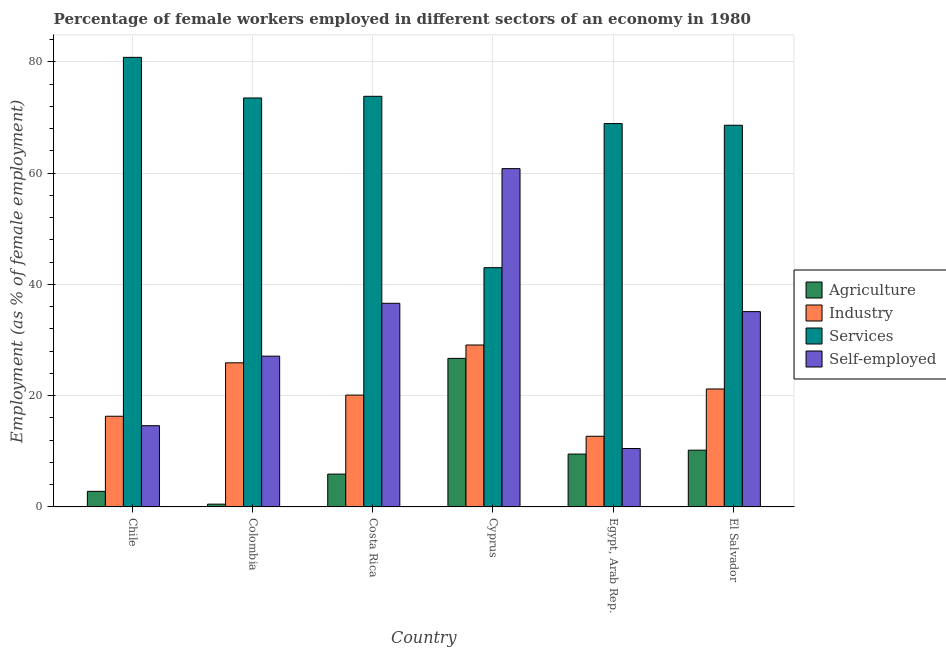How many groups of bars are there?
Your answer should be compact. 6. How many bars are there on the 3rd tick from the left?
Give a very brief answer. 4. What is the label of the 6th group of bars from the left?
Your answer should be very brief. El Salvador. In how many cases, is the number of bars for a given country not equal to the number of legend labels?
Ensure brevity in your answer.  0. What is the percentage of self employed female workers in El Salvador?
Ensure brevity in your answer.  35.1. Across all countries, what is the maximum percentage of female workers in services?
Your response must be concise. 80.8. Across all countries, what is the minimum percentage of female workers in agriculture?
Offer a terse response. 0.5. In which country was the percentage of female workers in agriculture maximum?
Offer a terse response. Cyprus. In which country was the percentage of female workers in services minimum?
Provide a succinct answer. Cyprus. What is the total percentage of female workers in services in the graph?
Give a very brief answer. 408.6. What is the difference between the percentage of female workers in industry in Chile and that in Egypt, Arab Rep.?
Your response must be concise. 3.6. What is the difference between the percentage of female workers in industry in Chile and the percentage of female workers in services in Costa Rica?
Give a very brief answer. -57.5. What is the average percentage of self employed female workers per country?
Your answer should be compact. 30.78. What is the difference between the percentage of female workers in services and percentage of female workers in agriculture in Chile?
Offer a terse response. 78. What is the ratio of the percentage of female workers in services in Chile to that in Costa Rica?
Keep it short and to the point. 1.09. Is the percentage of female workers in services in Chile less than that in Cyprus?
Ensure brevity in your answer.  No. Is the difference between the percentage of self employed female workers in Cyprus and Egypt, Arab Rep. greater than the difference between the percentage of female workers in services in Cyprus and Egypt, Arab Rep.?
Give a very brief answer. Yes. What is the difference between the highest and the second highest percentage of self employed female workers?
Keep it short and to the point. 24.2. What is the difference between the highest and the lowest percentage of female workers in industry?
Offer a very short reply. 16.4. In how many countries, is the percentage of self employed female workers greater than the average percentage of self employed female workers taken over all countries?
Provide a short and direct response. 3. Is it the case that in every country, the sum of the percentage of female workers in services and percentage of self employed female workers is greater than the sum of percentage of female workers in industry and percentage of female workers in agriculture?
Your response must be concise. No. What does the 4th bar from the left in Cyprus represents?
Offer a very short reply. Self-employed. What does the 1st bar from the right in Chile represents?
Ensure brevity in your answer.  Self-employed. How many countries are there in the graph?
Your response must be concise. 6. What is the difference between two consecutive major ticks on the Y-axis?
Ensure brevity in your answer.  20. Does the graph contain grids?
Your answer should be very brief. Yes. Where does the legend appear in the graph?
Your answer should be compact. Center right. How are the legend labels stacked?
Ensure brevity in your answer.  Vertical. What is the title of the graph?
Give a very brief answer. Percentage of female workers employed in different sectors of an economy in 1980. What is the label or title of the Y-axis?
Offer a terse response. Employment (as % of female employment). What is the Employment (as % of female employment) of Agriculture in Chile?
Provide a succinct answer. 2.8. What is the Employment (as % of female employment) in Industry in Chile?
Offer a very short reply. 16.3. What is the Employment (as % of female employment) of Services in Chile?
Make the answer very short. 80.8. What is the Employment (as % of female employment) of Self-employed in Chile?
Your answer should be compact. 14.6. What is the Employment (as % of female employment) in Agriculture in Colombia?
Offer a terse response. 0.5. What is the Employment (as % of female employment) in Industry in Colombia?
Offer a terse response. 25.9. What is the Employment (as % of female employment) in Services in Colombia?
Provide a short and direct response. 73.5. What is the Employment (as % of female employment) of Self-employed in Colombia?
Give a very brief answer. 27.1. What is the Employment (as % of female employment) of Agriculture in Costa Rica?
Offer a terse response. 5.9. What is the Employment (as % of female employment) in Industry in Costa Rica?
Offer a terse response. 20.1. What is the Employment (as % of female employment) in Services in Costa Rica?
Offer a very short reply. 73.8. What is the Employment (as % of female employment) of Self-employed in Costa Rica?
Offer a very short reply. 36.6. What is the Employment (as % of female employment) of Agriculture in Cyprus?
Provide a succinct answer. 26.7. What is the Employment (as % of female employment) in Industry in Cyprus?
Make the answer very short. 29.1. What is the Employment (as % of female employment) in Services in Cyprus?
Keep it short and to the point. 43. What is the Employment (as % of female employment) of Self-employed in Cyprus?
Provide a short and direct response. 60.8. What is the Employment (as % of female employment) in Agriculture in Egypt, Arab Rep.?
Your response must be concise. 9.5. What is the Employment (as % of female employment) of Industry in Egypt, Arab Rep.?
Make the answer very short. 12.7. What is the Employment (as % of female employment) of Services in Egypt, Arab Rep.?
Your response must be concise. 68.9. What is the Employment (as % of female employment) of Self-employed in Egypt, Arab Rep.?
Provide a short and direct response. 10.5. What is the Employment (as % of female employment) of Agriculture in El Salvador?
Provide a succinct answer. 10.2. What is the Employment (as % of female employment) of Industry in El Salvador?
Your response must be concise. 21.2. What is the Employment (as % of female employment) in Services in El Salvador?
Offer a very short reply. 68.6. What is the Employment (as % of female employment) of Self-employed in El Salvador?
Provide a succinct answer. 35.1. Across all countries, what is the maximum Employment (as % of female employment) of Agriculture?
Provide a short and direct response. 26.7. Across all countries, what is the maximum Employment (as % of female employment) in Industry?
Your answer should be compact. 29.1. Across all countries, what is the maximum Employment (as % of female employment) of Services?
Provide a short and direct response. 80.8. Across all countries, what is the maximum Employment (as % of female employment) of Self-employed?
Make the answer very short. 60.8. Across all countries, what is the minimum Employment (as % of female employment) in Industry?
Offer a terse response. 12.7. Across all countries, what is the minimum Employment (as % of female employment) in Services?
Keep it short and to the point. 43. What is the total Employment (as % of female employment) in Agriculture in the graph?
Your answer should be compact. 55.6. What is the total Employment (as % of female employment) of Industry in the graph?
Offer a very short reply. 125.3. What is the total Employment (as % of female employment) of Services in the graph?
Give a very brief answer. 408.6. What is the total Employment (as % of female employment) in Self-employed in the graph?
Make the answer very short. 184.7. What is the difference between the Employment (as % of female employment) in Agriculture in Chile and that in Colombia?
Your answer should be compact. 2.3. What is the difference between the Employment (as % of female employment) of Agriculture in Chile and that in Costa Rica?
Provide a short and direct response. -3.1. What is the difference between the Employment (as % of female employment) in Self-employed in Chile and that in Costa Rica?
Make the answer very short. -22. What is the difference between the Employment (as % of female employment) of Agriculture in Chile and that in Cyprus?
Ensure brevity in your answer.  -23.9. What is the difference between the Employment (as % of female employment) of Services in Chile and that in Cyprus?
Your answer should be very brief. 37.8. What is the difference between the Employment (as % of female employment) in Self-employed in Chile and that in Cyprus?
Ensure brevity in your answer.  -46.2. What is the difference between the Employment (as % of female employment) in Agriculture in Chile and that in Egypt, Arab Rep.?
Make the answer very short. -6.7. What is the difference between the Employment (as % of female employment) in Industry in Chile and that in Egypt, Arab Rep.?
Provide a short and direct response. 3.6. What is the difference between the Employment (as % of female employment) in Services in Chile and that in Egypt, Arab Rep.?
Offer a very short reply. 11.9. What is the difference between the Employment (as % of female employment) in Services in Chile and that in El Salvador?
Your answer should be compact. 12.2. What is the difference between the Employment (as % of female employment) of Self-employed in Chile and that in El Salvador?
Ensure brevity in your answer.  -20.5. What is the difference between the Employment (as % of female employment) of Agriculture in Colombia and that in Costa Rica?
Your answer should be compact. -5.4. What is the difference between the Employment (as % of female employment) in Services in Colombia and that in Costa Rica?
Your answer should be very brief. -0.3. What is the difference between the Employment (as % of female employment) in Agriculture in Colombia and that in Cyprus?
Make the answer very short. -26.2. What is the difference between the Employment (as % of female employment) in Industry in Colombia and that in Cyprus?
Ensure brevity in your answer.  -3.2. What is the difference between the Employment (as % of female employment) in Services in Colombia and that in Cyprus?
Provide a succinct answer. 30.5. What is the difference between the Employment (as % of female employment) of Self-employed in Colombia and that in Cyprus?
Offer a very short reply. -33.7. What is the difference between the Employment (as % of female employment) of Agriculture in Colombia and that in Egypt, Arab Rep.?
Your answer should be very brief. -9. What is the difference between the Employment (as % of female employment) of Industry in Colombia and that in Egypt, Arab Rep.?
Provide a succinct answer. 13.2. What is the difference between the Employment (as % of female employment) of Services in Colombia and that in Egypt, Arab Rep.?
Keep it short and to the point. 4.6. What is the difference between the Employment (as % of female employment) in Self-employed in Colombia and that in Egypt, Arab Rep.?
Make the answer very short. 16.6. What is the difference between the Employment (as % of female employment) in Agriculture in Costa Rica and that in Cyprus?
Offer a very short reply. -20.8. What is the difference between the Employment (as % of female employment) in Industry in Costa Rica and that in Cyprus?
Make the answer very short. -9. What is the difference between the Employment (as % of female employment) in Services in Costa Rica and that in Cyprus?
Make the answer very short. 30.8. What is the difference between the Employment (as % of female employment) in Self-employed in Costa Rica and that in Cyprus?
Give a very brief answer. -24.2. What is the difference between the Employment (as % of female employment) of Services in Costa Rica and that in Egypt, Arab Rep.?
Ensure brevity in your answer.  4.9. What is the difference between the Employment (as % of female employment) of Self-employed in Costa Rica and that in Egypt, Arab Rep.?
Provide a short and direct response. 26.1. What is the difference between the Employment (as % of female employment) of Agriculture in Costa Rica and that in El Salvador?
Your answer should be compact. -4.3. What is the difference between the Employment (as % of female employment) of Self-employed in Costa Rica and that in El Salvador?
Your answer should be compact. 1.5. What is the difference between the Employment (as % of female employment) of Industry in Cyprus and that in Egypt, Arab Rep.?
Keep it short and to the point. 16.4. What is the difference between the Employment (as % of female employment) in Services in Cyprus and that in Egypt, Arab Rep.?
Ensure brevity in your answer.  -25.9. What is the difference between the Employment (as % of female employment) of Self-employed in Cyprus and that in Egypt, Arab Rep.?
Keep it short and to the point. 50.3. What is the difference between the Employment (as % of female employment) in Services in Cyprus and that in El Salvador?
Your response must be concise. -25.6. What is the difference between the Employment (as % of female employment) in Self-employed in Cyprus and that in El Salvador?
Your response must be concise. 25.7. What is the difference between the Employment (as % of female employment) in Agriculture in Egypt, Arab Rep. and that in El Salvador?
Provide a short and direct response. -0.7. What is the difference between the Employment (as % of female employment) of Self-employed in Egypt, Arab Rep. and that in El Salvador?
Offer a very short reply. -24.6. What is the difference between the Employment (as % of female employment) of Agriculture in Chile and the Employment (as % of female employment) of Industry in Colombia?
Offer a very short reply. -23.1. What is the difference between the Employment (as % of female employment) in Agriculture in Chile and the Employment (as % of female employment) in Services in Colombia?
Offer a very short reply. -70.7. What is the difference between the Employment (as % of female employment) of Agriculture in Chile and the Employment (as % of female employment) of Self-employed in Colombia?
Your response must be concise. -24.3. What is the difference between the Employment (as % of female employment) in Industry in Chile and the Employment (as % of female employment) in Services in Colombia?
Provide a short and direct response. -57.2. What is the difference between the Employment (as % of female employment) in Services in Chile and the Employment (as % of female employment) in Self-employed in Colombia?
Provide a short and direct response. 53.7. What is the difference between the Employment (as % of female employment) of Agriculture in Chile and the Employment (as % of female employment) of Industry in Costa Rica?
Your response must be concise. -17.3. What is the difference between the Employment (as % of female employment) in Agriculture in Chile and the Employment (as % of female employment) in Services in Costa Rica?
Offer a terse response. -71. What is the difference between the Employment (as % of female employment) in Agriculture in Chile and the Employment (as % of female employment) in Self-employed in Costa Rica?
Provide a succinct answer. -33.8. What is the difference between the Employment (as % of female employment) in Industry in Chile and the Employment (as % of female employment) in Services in Costa Rica?
Ensure brevity in your answer.  -57.5. What is the difference between the Employment (as % of female employment) of Industry in Chile and the Employment (as % of female employment) of Self-employed in Costa Rica?
Provide a succinct answer. -20.3. What is the difference between the Employment (as % of female employment) in Services in Chile and the Employment (as % of female employment) in Self-employed in Costa Rica?
Your answer should be very brief. 44.2. What is the difference between the Employment (as % of female employment) in Agriculture in Chile and the Employment (as % of female employment) in Industry in Cyprus?
Make the answer very short. -26.3. What is the difference between the Employment (as % of female employment) in Agriculture in Chile and the Employment (as % of female employment) in Services in Cyprus?
Provide a short and direct response. -40.2. What is the difference between the Employment (as % of female employment) in Agriculture in Chile and the Employment (as % of female employment) in Self-employed in Cyprus?
Make the answer very short. -58. What is the difference between the Employment (as % of female employment) of Industry in Chile and the Employment (as % of female employment) of Services in Cyprus?
Provide a short and direct response. -26.7. What is the difference between the Employment (as % of female employment) of Industry in Chile and the Employment (as % of female employment) of Self-employed in Cyprus?
Your response must be concise. -44.5. What is the difference between the Employment (as % of female employment) in Services in Chile and the Employment (as % of female employment) in Self-employed in Cyprus?
Ensure brevity in your answer.  20. What is the difference between the Employment (as % of female employment) in Agriculture in Chile and the Employment (as % of female employment) in Services in Egypt, Arab Rep.?
Your answer should be very brief. -66.1. What is the difference between the Employment (as % of female employment) in Industry in Chile and the Employment (as % of female employment) in Services in Egypt, Arab Rep.?
Your response must be concise. -52.6. What is the difference between the Employment (as % of female employment) in Services in Chile and the Employment (as % of female employment) in Self-employed in Egypt, Arab Rep.?
Keep it short and to the point. 70.3. What is the difference between the Employment (as % of female employment) of Agriculture in Chile and the Employment (as % of female employment) of Industry in El Salvador?
Offer a very short reply. -18.4. What is the difference between the Employment (as % of female employment) in Agriculture in Chile and the Employment (as % of female employment) in Services in El Salvador?
Your answer should be compact. -65.8. What is the difference between the Employment (as % of female employment) in Agriculture in Chile and the Employment (as % of female employment) in Self-employed in El Salvador?
Ensure brevity in your answer.  -32.3. What is the difference between the Employment (as % of female employment) in Industry in Chile and the Employment (as % of female employment) in Services in El Salvador?
Keep it short and to the point. -52.3. What is the difference between the Employment (as % of female employment) in Industry in Chile and the Employment (as % of female employment) in Self-employed in El Salvador?
Keep it short and to the point. -18.8. What is the difference between the Employment (as % of female employment) in Services in Chile and the Employment (as % of female employment) in Self-employed in El Salvador?
Your answer should be compact. 45.7. What is the difference between the Employment (as % of female employment) of Agriculture in Colombia and the Employment (as % of female employment) of Industry in Costa Rica?
Your answer should be compact. -19.6. What is the difference between the Employment (as % of female employment) of Agriculture in Colombia and the Employment (as % of female employment) of Services in Costa Rica?
Give a very brief answer. -73.3. What is the difference between the Employment (as % of female employment) of Agriculture in Colombia and the Employment (as % of female employment) of Self-employed in Costa Rica?
Give a very brief answer. -36.1. What is the difference between the Employment (as % of female employment) of Industry in Colombia and the Employment (as % of female employment) of Services in Costa Rica?
Offer a terse response. -47.9. What is the difference between the Employment (as % of female employment) of Industry in Colombia and the Employment (as % of female employment) of Self-employed in Costa Rica?
Offer a terse response. -10.7. What is the difference between the Employment (as % of female employment) in Services in Colombia and the Employment (as % of female employment) in Self-employed in Costa Rica?
Provide a succinct answer. 36.9. What is the difference between the Employment (as % of female employment) in Agriculture in Colombia and the Employment (as % of female employment) in Industry in Cyprus?
Offer a terse response. -28.6. What is the difference between the Employment (as % of female employment) of Agriculture in Colombia and the Employment (as % of female employment) of Services in Cyprus?
Keep it short and to the point. -42.5. What is the difference between the Employment (as % of female employment) in Agriculture in Colombia and the Employment (as % of female employment) in Self-employed in Cyprus?
Offer a terse response. -60.3. What is the difference between the Employment (as % of female employment) of Industry in Colombia and the Employment (as % of female employment) of Services in Cyprus?
Your answer should be very brief. -17.1. What is the difference between the Employment (as % of female employment) of Industry in Colombia and the Employment (as % of female employment) of Self-employed in Cyprus?
Offer a terse response. -34.9. What is the difference between the Employment (as % of female employment) in Services in Colombia and the Employment (as % of female employment) in Self-employed in Cyprus?
Give a very brief answer. 12.7. What is the difference between the Employment (as % of female employment) of Agriculture in Colombia and the Employment (as % of female employment) of Services in Egypt, Arab Rep.?
Provide a short and direct response. -68.4. What is the difference between the Employment (as % of female employment) of Agriculture in Colombia and the Employment (as % of female employment) of Self-employed in Egypt, Arab Rep.?
Your answer should be very brief. -10. What is the difference between the Employment (as % of female employment) of Industry in Colombia and the Employment (as % of female employment) of Services in Egypt, Arab Rep.?
Offer a very short reply. -43. What is the difference between the Employment (as % of female employment) in Industry in Colombia and the Employment (as % of female employment) in Self-employed in Egypt, Arab Rep.?
Your answer should be very brief. 15.4. What is the difference between the Employment (as % of female employment) of Agriculture in Colombia and the Employment (as % of female employment) of Industry in El Salvador?
Your response must be concise. -20.7. What is the difference between the Employment (as % of female employment) of Agriculture in Colombia and the Employment (as % of female employment) of Services in El Salvador?
Keep it short and to the point. -68.1. What is the difference between the Employment (as % of female employment) of Agriculture in Colombia and the Employment (as % of female employment) of Self-employed in El Salvador?
Your response must be concise. -34.6. What is the difference between the Employment (as % of female employment) in Industry in Colombia and the Employment (as % of female employment) in Services in El Salvador?
Give a very brief answer. -42.7. What is the difference between the Employment (as % of female employment) in Services in Colombia and the Employment (as % of female employment) in Self-employed in El Salvador?
Give a very brief answer. 38.4. What is the difference between the Employment (as % of female employment) of Agriculture in Costa Rica and the Employment (as % of female employment) of Industry in Cyprus?
Keep it short and to the point. -23.2. What is the difference between the Employment (as % of female employment) of Agriculture in Costa Rica and the Employment (as % of female employment) of Services in Cyprus?
Ensure brevity in your answer.  -37.1. What is the difference between the Employment (as % of female employment) in Agriculture in Costa Rica and the Employment (as % of female employment) in Self-employed in Cyprus?
Provide a short and direct response. -54.9. What is the difference between the Employment (as % of female employment) in Industry in Costa Rica and the Employment (as % of female employment) in Services in Cyprus?
Offer a terse response. -22.9. What is the difference between the Employment (as % of female employment) of Industry in Costa Rica and the Employment (as % of female employment) of Self-employed in Cyprus?
Your answer should be compact. -40.7. What is the difference between the Employment (as % of female employment) in Services in Costa Rica and the Employment (as % of female employment) in Self-employed in Cyprus?
Make the answer very short. 13. What is the difference between the Employment (as % of female employment) of Agriculture in Costa Rica and the Employment (as % of female employment) of Industry in Egypt, Arab Rep.?
Give a very brief answer. -6.8. What is the difference between the Employment (as % of female employment) of Agriculture in Costa Rica and the Employment (as % of female employment) of Services in Egypt, Arab Rep.?
Give a very brief answer. -63. What is the difference between the Employment (as % of female employment) in Agriculture in Costa Rica and the Employment (as % of female employment) in Self-employed in Egypt, Arab Rep.?
Keep it short and to the point. -4.6. What is the difference between the Employment (as % of female employment) in Industry in Costa Rica and the Employment (as % of female employment) in Services in Egypt, Arab Rep.?
Your answer should be compact. -48.8. What is the difference between the Employment (as % of female employment) in Industry in Costa Rica and the Employment (as % of female employment) in Self-employed in Egypt, Arab Rep.?
Your answer should be very brief. 9.6. What is the difference between the Employment (as % of female employment) in Services in Costa Rica and the Employment (as % of female employment) in Self-employed in Egypt, Arab Rep.?
Ensure brevity in your answer.  63.3. What is the difference between the Employment (as % of female employment) of Agriculture in Costa Rica and the Employment (as % of female employment) of Industry in El Salvador?
Make the answer very short. -15.3. What is the difference between the Employment (as % of female employment) in Agriculture in Costa Rica and the Employment (as % of female employment) in Services in El Salvador?
Your response must be concise. -62.7. What is the difference between the Employment (as % of female employment) in Agriculture in Costa Rica and the Employment (as % of female employment) in Self-employed in El Salvador?
Make the answer very short. -29.2. What is the difference between the Employment (as % of female employment) of Industry in Costa Rica and the Employment (as % of female employment) of Services in El Salvador?
Provide a succinct answer. -48.5. What is the difference between the Employment (as % of female employment) in Services in Costa Rica and the Employment (as % of female employment) in Self-employed in El Salvador?
Your answer should be compact. 38.7. What is the difference between the Employment (as % of female employment) in Agriculture in Cyprus and the Employment (as % of female employment) in Industry in Egypt, Arab Rep.?
Provide a succinct answer. 14. What is the difference between the Employment (as % of female employment) in Agriculture in Cyprus and the Employment (as % of female employment) in Services in Egypt, Arab Rep.?
Your answer should be very brief. -42.2. What is the difference between the Employment (as % of female employment) of Agriculture in Cyprus and the Employment (as % of female employment) of Self-employed in Egypt, Arab Rep.?
Ensure brevity in your answer.  16.2. What is the difference between the Employment (as % of female employment) of Industry in Cyprus and the Employment (as % of female employment) of Services in Egypt, Arab Rep.?
Offer a terse response. -39.8. What is the difference between the Employment (as % of female employment) of Services in Cyprus and the Employment (as % of female employment) of Self-employed in Egypt, Arab Rep.?
Your response must be concise. 32.5. What is the difference between the Employment (as % of female employment) of Agriculture in Cyprus and the Employment (as % of female employment) of Industry in El Salvador?
Your answer should be compact. 5.5. What is the difference between the Employment (as % of female employment) of Agriculture in Cyprus and the Employment (as % of female employment) of Services in El Salvador?
Your response must be concise. -41.9. What is the difference between the Employment (as % of female employment) in Industry in Cyprus and the Employment (as % of female employment) in Services in El Salvador?
Give a very brief answer. -39.5. What is the difference between the Employment (as % of female employment) in Industry in Cyprus and the Employment (as % of female employment) in Self-employed in El Salvador?
Give a very brief answer. -6. What is the difference between the Employment (as % of female employment) in Agriculture in Egypt, Arab Rep. and the Employment (as % of female employment) in Industry in El Salvador?
Keep it short and to the point. -11.7. What is the difference between the Employment (as % of female employment) of Agriculture in Egypt, Arab Rep. and the Employment (as % of female employment) of Services in El Salvador?
Keep it short and to the point. -59.1. What is the difference between the Employment (as % of female employment) in Agriculture in Egypt, Arab Rep. and the Employment (as % of female employment) in Self-employed in El Salvador?
Keep it short and to the point. -25.6. What is the difference between the Employment (as % of female employment) of Industry in Egypt, Arab Rep. and the Employment (as % of female employment) of Services in El Salvador?
Offer a very short reply. -55.9. What is the difference between the Employment (as % of female employment) in Industry in Egypt, Arab Rep. and the Employment (as % of female employment) in Self-employed in El Salvador?
Make the answer very short. -22.4. What is the difference between the Employment (as % of female employment) of Services in Egypt, Arab Rep. and the Employment (as % of female employment) of Self-employed in El Salvador?
Offer a terse response. 33.8. What is the average Employment (as % of female employment) in Agriculture per country?
Keep it short and to the point. 9.27. What is the average Employment (as % of female employment) of Industry per country?
Provide a short and direct response. 20.88. What is the average Employment (as % of female employment) of Services per country?
Provide a short and direct response. 68.1. What is the average Employment (as % of female employment) of Self-employed per country?
Your answer should be compact. 30.78. What is the difference between the Employment (as % of female employment) in Agriculture and Employment (as % of female employment) in Services in Chile?
Your response must be concise. -78. What is the difference between the Employment (as % of female employment) in Industry and Employment (as % of female employment) in Services in Chile?
Provide a short and direct response. -64.5. What is the difference between the Employment (as % of female employment) in Industry and Employment (as % of female employment) in Self-employed in Chile?
Ensure brevity in your answer.  1.7. What is the difference between the Employment (as % of female employment) of Services and Employment (as % of female employment) of Self-employed in Chile?
Keep it short and to the point. 66.2. What is the difference between the Employment (as % of female employment) in Agriculture and Employment (as % of female employment) in Industry in Colombia?
Your answer should be very brief. -25.4. What is the difference between the Employment (as % of female employment) in Agriculture and Employment (as % of female employment) in Services in Colombia?
Give a very brief answer. -73. What is the difference between the Employment (as % of female employment) in Agriculture and Employment (as % of female employment) in Self-employed in Colombia?
Provide a short and direct response. -26.6. What is the difference between the Employment (as % of female employment) in Industry and Employment (as % of female employment) in Services in Colombia?
Your answer should be compact. -47.6. What is the difference between the Employment (as % of female employment) of Industry and Employment (as % of female employment) of Self-employed in Colombia?
Your answer should be very brief. -1.2. What is the difference between the Employment (as % of female employment) in Services and Employment (as % of female employment) in Self-employed in Colombia?
Your response must be concise. 46.4. What is the difference between the Employment (as % of female employment) in Agriculture and Employment (as % of female employment) in Services in Costa Rica?
Keep it short and to the point. -67.9. What is the difference between the Employment (as % of female employment) in Agriculture and Employment (as % of female employment) in Self-employed in Costa Rica?
Give a very brief answer. -30.7. What is the difference between the Employment (as % of female employment) in Industry and Employment (as % of female employment) in Services in Costa Rica?
Give a very brief answer. -53.7. What is the difference between the Employment (as % of female employment) of Industry and Employment (as % of female employment) of Self-employed in Costa Rica?
Offer a very short reply. -16.5. What is the difference between the Employment (as % of female employment) of Services and Employment (as % of female employment) of Self-employed in Costa Rica?
Make the answer very short. 37.2. What is the difference between the Employment (as % of female employment) in Agriculture and Employment (as % of female employment) in Industry in Cyprus?
Your response must be concise. -2.4. What is the difference between the Employment (as % of female employment) in Agriculture and Employment (as % of female employment) in Services in Cyprus?
Ensure brevity in your answer.  -16.3. What is the difference between the Employment (as % of female employment) of Agriculture and Employment (as % of female employment) of Self-employed in Cyprus?
Your answer should be compact. -34.1. What is the difference between the Employment (as % of female employment) of Industry and Employment (as % of female employment) of Self-employed in Cyprus?
Make the answer very short. -31.7. What is the difference between the Employment (as % of female employment) of Services and Employment (as % of female employment) of Self-employed in Cyprus?
Keep it short and to the point. -17.8. What is the difference between the Employment (as % of female employment) in Agriculture and Employment (as % of female employment) in Industry in Egypt, Arab Rep.?
Your answer should be very brief. -3.2. What is the difference between the Employment (as % of female employment) of Agriculture and Employment (as % of female employment) of Services in Egypt, Arab Rep.?
Ensure brevity in your answer.  -59.4. What is the difference between the Employment (as % of female employment) of Agriculture and Employment (as % of female employment) of Self-employed in Egypt, Arab Rep.?
Offer a terse response. -1. What is the difference between the Employment (as % of female employment) in Industry and Employment (as % of female employment) in Services in Egypt, Arab Rep.?
Your answer should be very brief. -56.2. What is the difference between the Employment (as % of female employment) of Industry and Employment (as % of female employment) of Self-employed in Egypt, Arab Rep.?
Keep it short and to the point. 2.2. What is the difference between the Employment (as % of female employment) in Services and Employment (as % of female employment) in Self-employed in Egypt, Arab Rep.?
Keep it short and to the point. 58.4. What is the difference between the Employment (as % of female employment) of Agriculture and Employment (as % of female employment) of Industry in El Salvador?
Ensure brevity in your answer.  -11. What is the difference between the Employment (as % of female employment) in Agriculture and Employment (as % of female employment) in Services in El Salvador?
Ensure brevity in your answer.  -58.4. What is the difference between the Employment (as % of female employment) in Agriculture and Employment (as % of female employment) in Self-employed in El Salvador?
Your answer should be compact. -24.9. What is the difference between the Employment (as % of female employment) in Industry and Employment (as % of female employment) in Services in El Salvador?
Provide a short and direct response. -47.4. What is the difference between the Employment (as % of female employment) in Services and Employment (as % of female employment) in Self-employed in El Salvador?
Keep it short and to the point. 33.5. What is the ratio of the Employment (as % of female employment) in Industry in Chile to that in Colombia?
Your response must be concise. 0.63. What is the ratio of the Employment (as % of female employment) of Services in Chile to that in Colombia?
Provide a short and direct response. 1.1. What is the ratio of the Employment (as % of female employment) in Self-employed in Chile to that in Colombia?
Give a very brief answer. 0.54. What is the ratio of the Employment (as % of female employment) in Agriculture in Chile to that in Costa Rica?
Keep it short and to the point. 0.47. What is the ratio of the Employment (as % of female employment) in Industry in Chile to that in Costa Rica?
Give a very brief answer. 0.81. What is the ratio of the Employment (as % of female employment) in Services in Chile to that in Costa Rica?
Give a very brief answer. 1.09. What is the ratio of the Employment (as % of female employment) in Self-employed in Chile to that in Costa Rica?
Keep it short and to the point. 0.4. What is the ratio of the Employment (as % of female employment) in Agriculture in Chile to that in Cyprus?
Make the answer very short. 0.1. What is the ratio of the Employment (as % of female employment) of Industry in Chile to that in Cyprus?
Your answer should be very brief. 0.56. What is the ratio of the Employment (as % of female employment) in Services in Chile to that in Cyprus?
Make the answer very short. 1.88. What is the ratio of the Employment (as % of female employment) in Self-employed in Chile to that in Cyprus?
Keep it short and to the point. 0.24. What is the ratio of the Employment (as % of female employment) of Agriculture in Chile to that in Egypt, Arab Rep.?
Your answer should be compact. 0.29. What is the ratio of the Employment (as % of female employment) in Industry in Chile to that in Egypt, Arab Rep.?
Offer a terse response. 1.28. What is the ratio of the Employment (as % of female employment) in Services in Chile to that in Egypt, Arab Rep.?
Your response must be concise. 1.17. What is the ratio of the Employment (as % of female employment) in Self-employed in Chile to that in Egypt, Arab Rep.?
Ensure brevity in your answer.  1.39. What is the ratio of the Employment (as % of female employment) in Agriculture in Chile to that in El Salvador?
Offer a very short reply. 0.27. What is the ratio of the Employment (as % of female employment) of Industry in Chile to that in El Salvador?
Provide a short and direct response. 0.77. What is the ratio of the Employment (as % of female employment) in Services in Chile to that in El Salvador?
Ensure brevity in your answer.  1.18. What is the ratio of the Employment (as % of female employment) of Self-employed in Chile to that in El Salvador?
Offer a terse response. 0.42. What is the ratio of the Employment (as % of female employment) in Agriculture in Colombia to that in Costa Rica?
Ensure brevity in your answer.  0.08. What is the ratio of the Employment (as % of female employment) of Industry in Colombia to that in Costa Rica?
Give a very brief answer. 1.29. What is the ratio of the Employment (as % of female employment) of Services in Colombia to that in Costa Rica?
Provide a succinct answer. 1. What is the ratio of the Employment (as % of female employment) in Self-employed in Colombia to that in Costa Rica?
Your response must be concise. 0.74. What is the ratio of the Employment (as % of female employment) of Agriculture in Colombia to that in Cyprus?
Keep it short and to the point. 0.02. What is the ratio of the Employment (as % of female employment) in Industry in Colombia to that in Cyprus?
Your response must be concise. 0.89. What is the ratio of the Employment (as % of female employment) in Services in Colombia to that in Cyprus?
Your answer should be compact. 1.71. What is the ratio of the Employment (as % of female employment) in Self-employed in Colombia to that in Cyprus?
Give a very brief answer. 0.45. What is the ratio of the Employment (as % of female employment) in Agriculture in Colombia to that in Egypt, Arab Rep.?
Provide a succinct answer. 0.05. What is the ratio of the Employment (as % of female employment) in Industry in Colombia to that in Egypt, Arab Rep.?
Offer a very short reply. 2.04. What is the ratio of the Employment (as % of female employment) of Services in Colombia to that in Egypt, Arab Rep.?
Provide a succinct answer. 1.07. What is the ratio of the Employment (as % of female employment) in Self-employed in Colombia to that in Egypt, Arab Rep.?
Ensure brevity in your answer.  2.58. What is the ratio of the Employment (as % of female employment) of Agriculture in Colombia to that in El Salvador?
Your response must be concise. 0.05. What is the ratio of the Employment (as % of female employment) in Industry in Colombia to that in El Salvador?
Offer a terse response. 1.22. What is the ratio of the Employment (as % of female employment) of Services in Colombia to that in El Salvador?
Offer a very short reply. 1.07. What is the ratio of the Employment (as % of female employment) of Self-employed in Colombia to that in El Salvador?
Provide a short and direct response. 0.77. What is the ratio of the Employment (as % of female employment) in Agriculture in Costa Rica to that in Cyprus?
Offer a terse response. 0.22. What is the ratio of the Employment (as % of female employment) in Industry in Costa Rica to that in Cyprus?
Keep it short and to the point. 0.69. What is the ratio of the Employment (as % of female employment) in Services in Costa Rica to that in Cyprus?
Keep it short and to the point. 1.72. What is the ratio of the Employment (as % of female employment) of Self-employed in Costa Rica to that in Cyprus?
Ensure brevity in your answer.  0.6. What is the ratio of the Employment (as % of female employment) in Agriculture in Costa Rica to that in Egypt, Arab Rep.?
Provide a succinct answer. 0.62. What is the ratio of the Employment (as % of female employment) of Industry in Costa Rica to that in Egypt, Arab Rep.?
Provide a succinct answer. 1.58. What is the ratio of the Employment (as % of female employment) of Services in Costa Rica to that in Egypt, Arab Rep.?
Ensure brevity in your answer.  1.07. What is the ratio of the Employment (as % of female employment) of Self-employed in Costa Rica to that in Egypt, Arab Rep.?
Your answer should be very brief. 3.49. What is the ratio of the Employment (as % of female employment) of Agriculture in Costa Rica to that in El Salvador?
Offer a very short reply. 0.58. What is the ratio of the Employment (as % of female employment) of Industry in Costa Rica to that in El Salvador?
Provide a succinct answer. 0.95. What is the ratio of the Employment (as % of female employment) of Services in Costa Rica to that in El Salvador?
Keep it short and to the point. 1.08. What is the ratio of the Employment (as % of female employment) of Self-employed in Costa Rica to that in El Salvador?
Provide a succinct answer. 1.04. What is the ratio of the Employment (as % of female employment) in Agriculture in Cyprus to that in Egypt, Arab Rep.?
Provide a short and direct response. 2.81. What is the ratio of the Employment (as % of female employment) in Industry in Cyprus to that in Egypt, Arab Rep.?
Ensure brevity in your answer.  2.29. What is the ratio of the Employment (as % of female employment) of Services in Cyprus to that in Egypt, Arab Rep.?
Ensure brevity in your answer.  0.62. What is the ratio of the Employment (as % of female employment) in Self-employed in Cyprus to that in Egypt, Arab Rep.?
Give a very brief answer. 5.79. What is the ratio of the Employment (as % of female employment) of Agriculture in Cyprus to that in El Salvador?
Ensure brevity in your answer.  2.62. What is the ratio of the Employment (as % of female employment) in Industry in Cyprus to that in El Salvador?
Offer a very short reply. 1.37. What is the ratio of the Employment (as % of female employment) of Services in Cyprus to that in El Salvador?
Ensure brevity in your answer.  0.63. What is the ratio of the Employment (as % of female employment) of Self-employed in Cyprus to that in El Salvador?
Your answer should be compact. 1.73. What is the ratio of the Employment (as % of female employment) of Agriculture in Egypt, Arab Rep. to that in El Salvador?
Provide a succinct answer. 0.93. What is the ratio of the Employment (as % of female employment) of Industry in Egypt, Arab Rep. to that in El Salvador?
Offer a very short reply. 0.6. What is the ratio of the Employment (as % of female employment) of Services in Egypt, Arab Rep. to that in El Salvador?
Your answer should be compact. 1. What is the ratio of the Employment (as % of female employment) in Self-employed in Egypt, Arab Rep. to that in El Salvador?
Your answer should be very brief. 0.3. What is the difference between the highest and the second highest Employment (as % of female employment) of Agriculture?
Offer a terse response. 16.5. What is the difference between the highest and the second highest Employment (as % of female employment) in Industry?
Ensure brevity in your answer.  3.2. What is the difference between the highest and the second highest Employment (as % of female employment) in Self-employed?
Provide a succinct answer. 24.2. What is the difference between the highest and the lowest Employment (as % of female employment) of Agriculture?
Offer a very short reply. 26.2. What is the difference between the highest and the lowest Employment (as % of female employment) in Services?
Offer a very short reply. 37.8. What is the difference between the highest and the lowest Employment (as % of female employment) of Self-employed?
Your response must be concise. 50.3. 